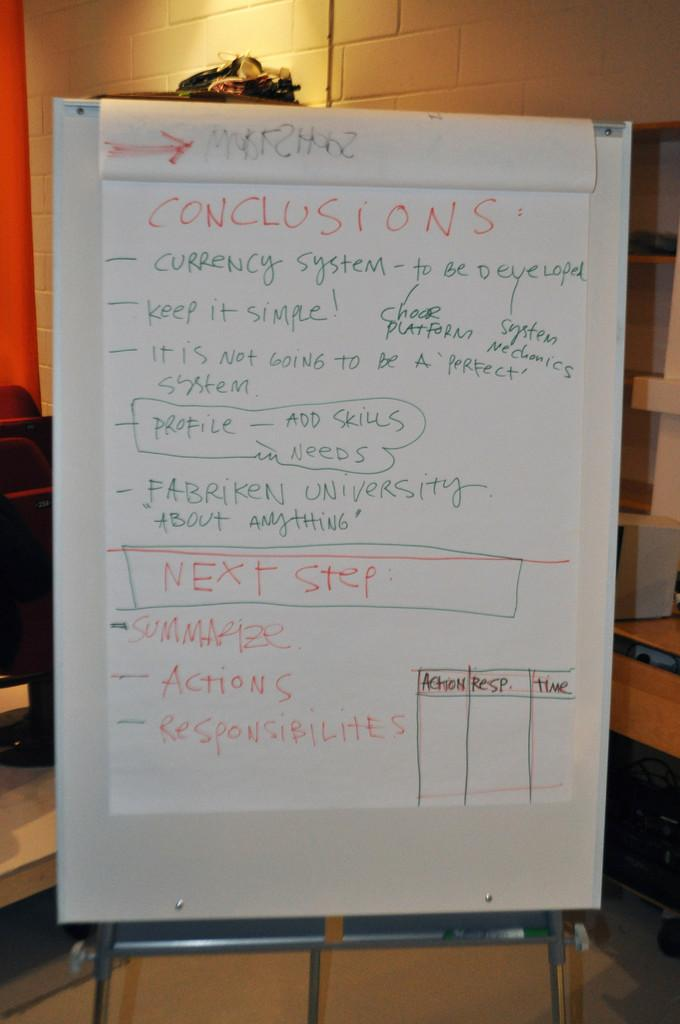<image>
Describe the image concisely. A large piece of paper covered in red, green and orange writing, the top word being CONCLUSIONS. 